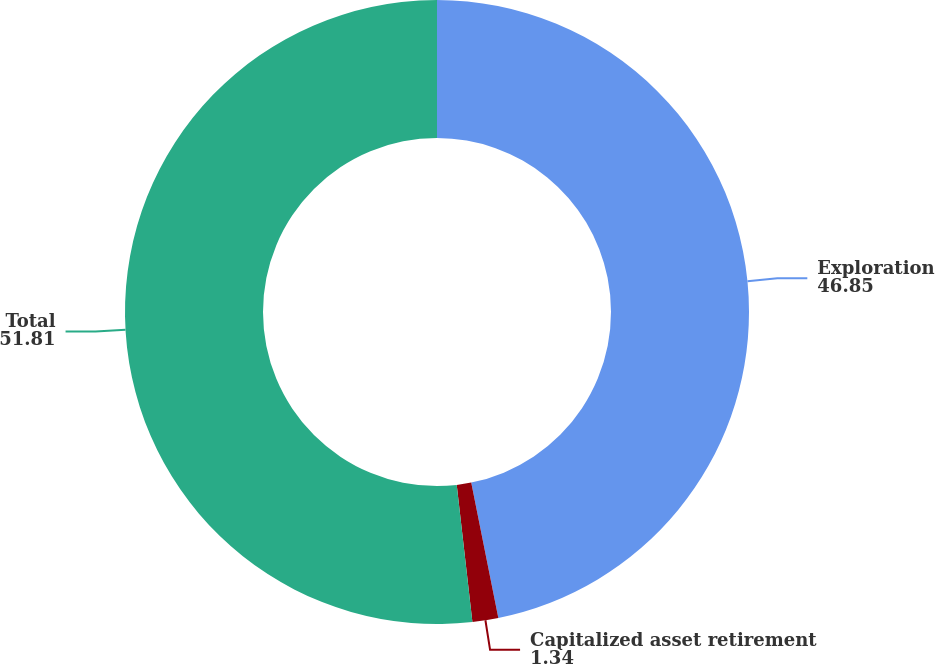Convert chart. <chart><loc_0><loc_0><loc_500><loc_500><pie_chart><fcel>Exploration<fcel>Capitalized asset retirement<fcel>Total<nl><fcel>46.85%<fcel>1.34%<fcel>51.81%<nl></chart> 